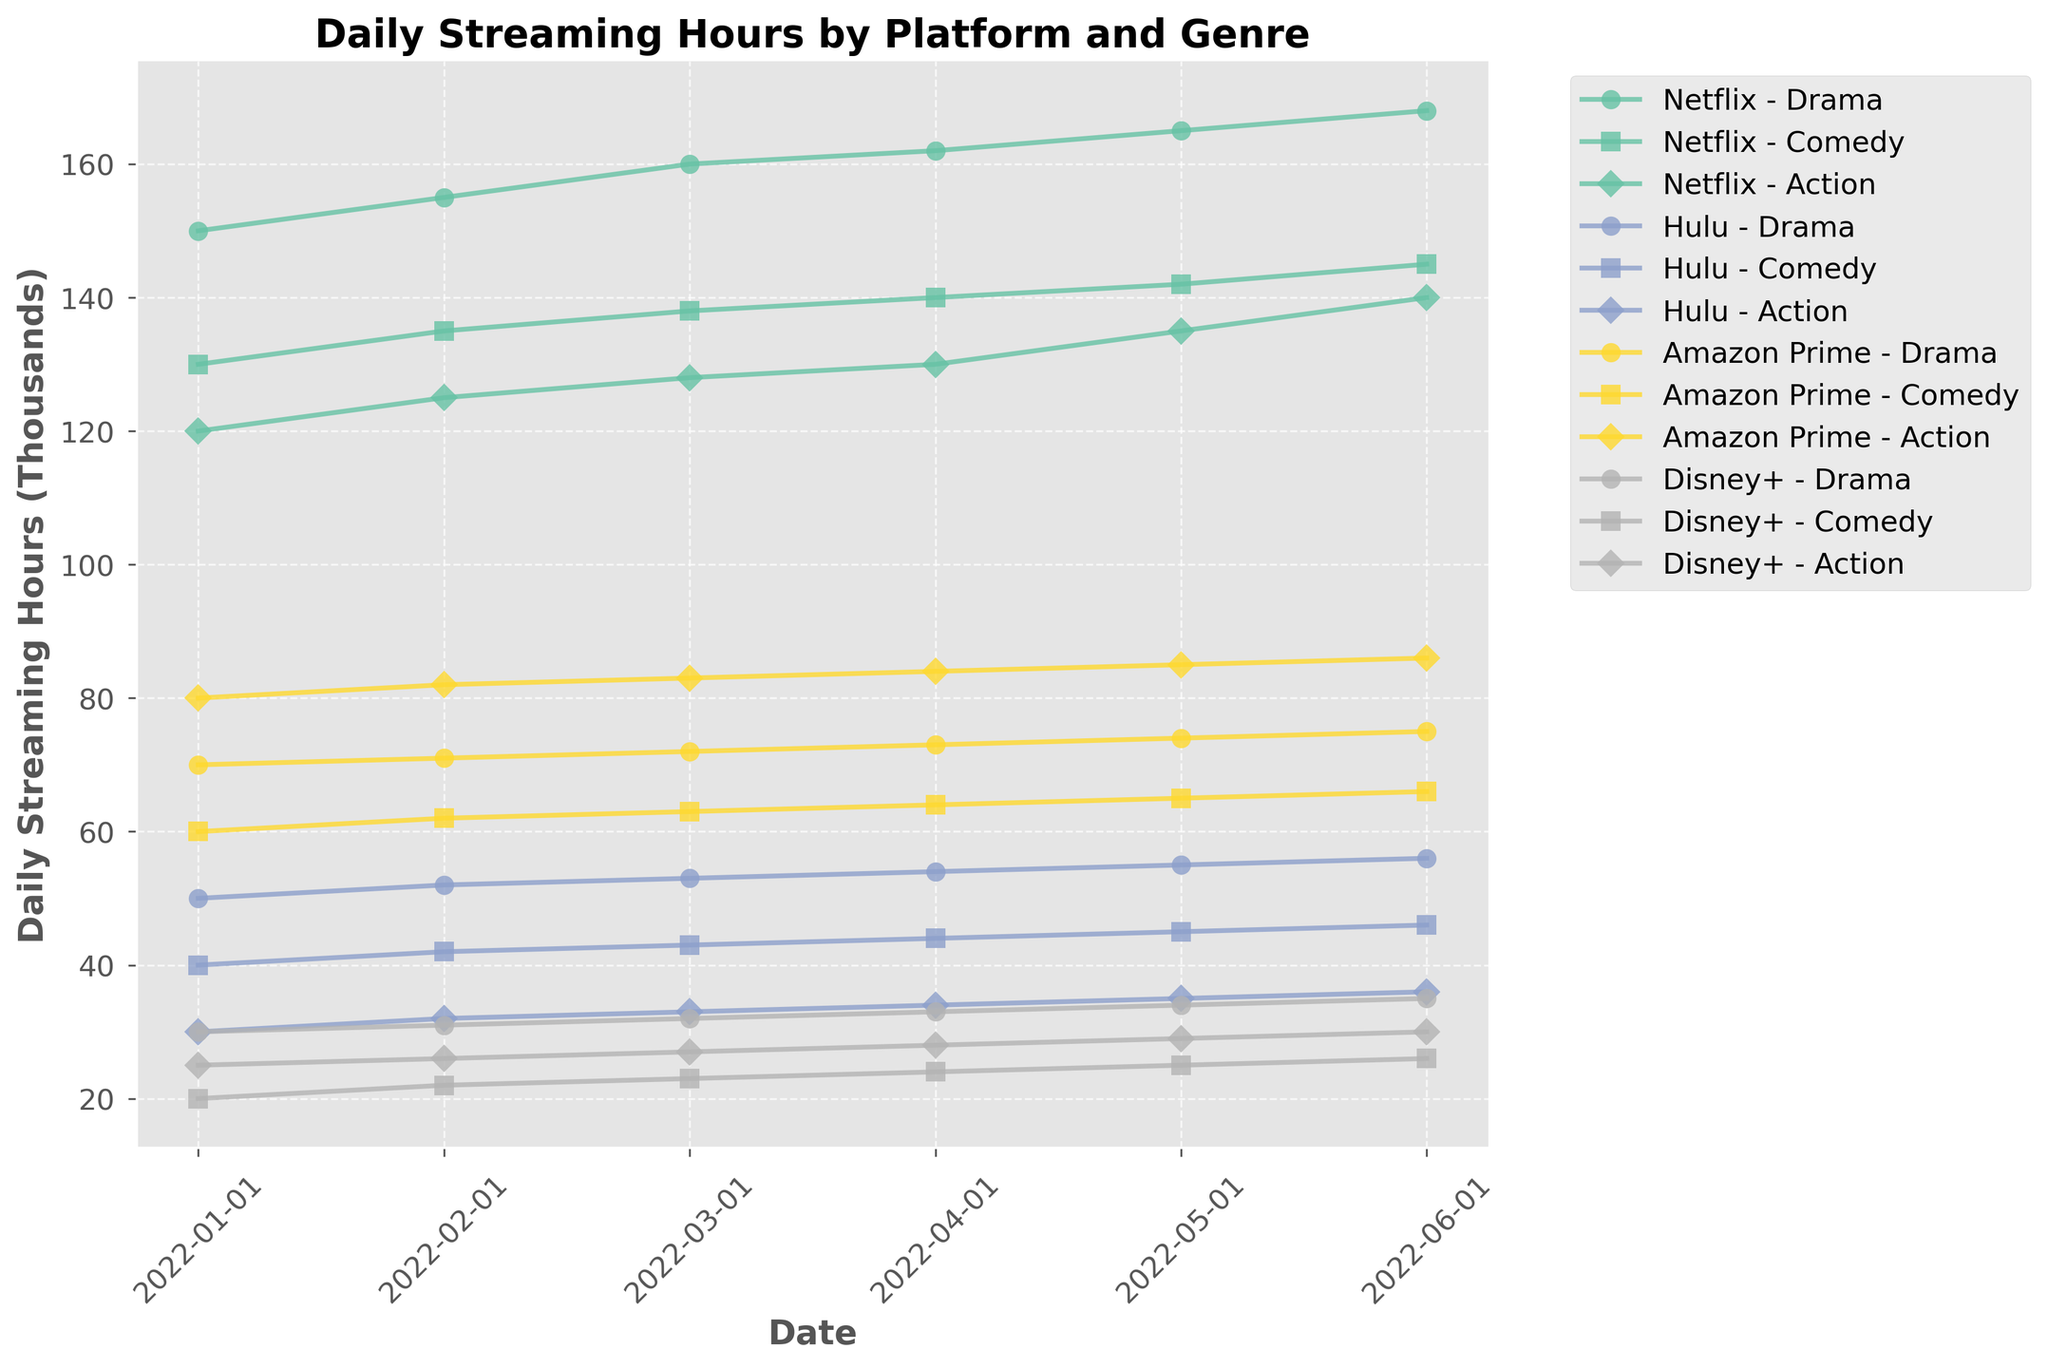What is the title of the figure? The title of the figure is displayed at the top and reads "Daily Streaming Hours by Platform and Genre".
Answer: Daily Streaming Hours by Platform and Genre How many platforms are represented in the figure? There are four unique colors in the plot corresponding to the different platforms, and the legend lists the platforms as Netflix, Hulu, Amazon Prime, and Disney+.
Answer: Four What is the range of dates represented on the x-axis? The x-axis has dates ticked, ranging from the earliest date, which is January 2022, to the latest date, which is June 2022.
Answer: January 2022 to June 2022 Which platform and genre combination has the highest daily streaming hours in April 2022? In April 2022, the lines in the plot show the highest point for the combination of Netflix and Drama at 162,000 hours (or 162 on the y-axis since it is in thousands).
Answer: Netflix - Drama Compare the daily streaming hours for Netflix vs. Hulu in February 2022 for the Comedy genre. Which platform has more streaming hours? In February 2022, for the Comedy genre, the point for Netflix is at 135,000 hours, while Hulu is at 42,000 hours. Netflix has more streaming hours.
Answer: Netflix By how much do the daily streaming hours for Netflix-Action increase from January 2022 to June 2022? Starting from 120,000 hours (January) and ending at 140,000 hours (June) for Netflix-Action, the increase can be calculated as 140,000 - 120,000 = 20,000 hours.
Answer: 20,000 hours Which platform and genre combination seems to have the steadiest increase in streaming hours over the shown period? Netflix-Drama consistently shows an upward trend with incremental increases month over month from January to June 2022.
Answer: Netflix - Drama Are there any months where Hulu-Comedy outperforms Amazon Prime-Comedy in daily streaming hours? By tracing the Hulu-Comedy and Amazon Prime-Comedy lines, it is evident that in none of the months does Hulu-Comedy outperform Amazon Prime-Comedy.
Answer: No What is the average daily streaming hours for Disney+ Drama from January 2022 to June 2022? Summing the streaming hours for Disney+ Drama across each month: 30,000 + 31,000 + 32,000 + 33,000 + 34,000 + 35,000 = 195,000. Dividing by 6 months, the average is 195,000 / 6 = 32,500 hours.
Answer: 32,500 hours 